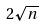Convert formula to latex. <formula><loc_0><loc_0><loc_500><loc_500>2 \sqrt { n }</formula> 